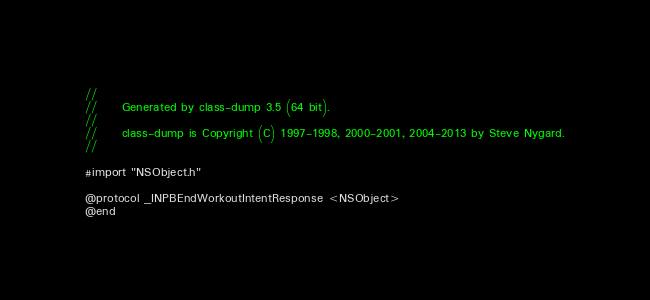<code> <loc_0><loc_0><loc_500><loc_500><_C_>//
//     Generated by class-dump 3.5 (64 bit).
//
//     class-dump is Copyright (C) 1997-1998, 2000-2001, 2004-2013 by Steve Nygard.
//

#import "NSObject.h"

@protocol _INPBEndWorkoutIntentResponse <NSObject>
@end

</code> 